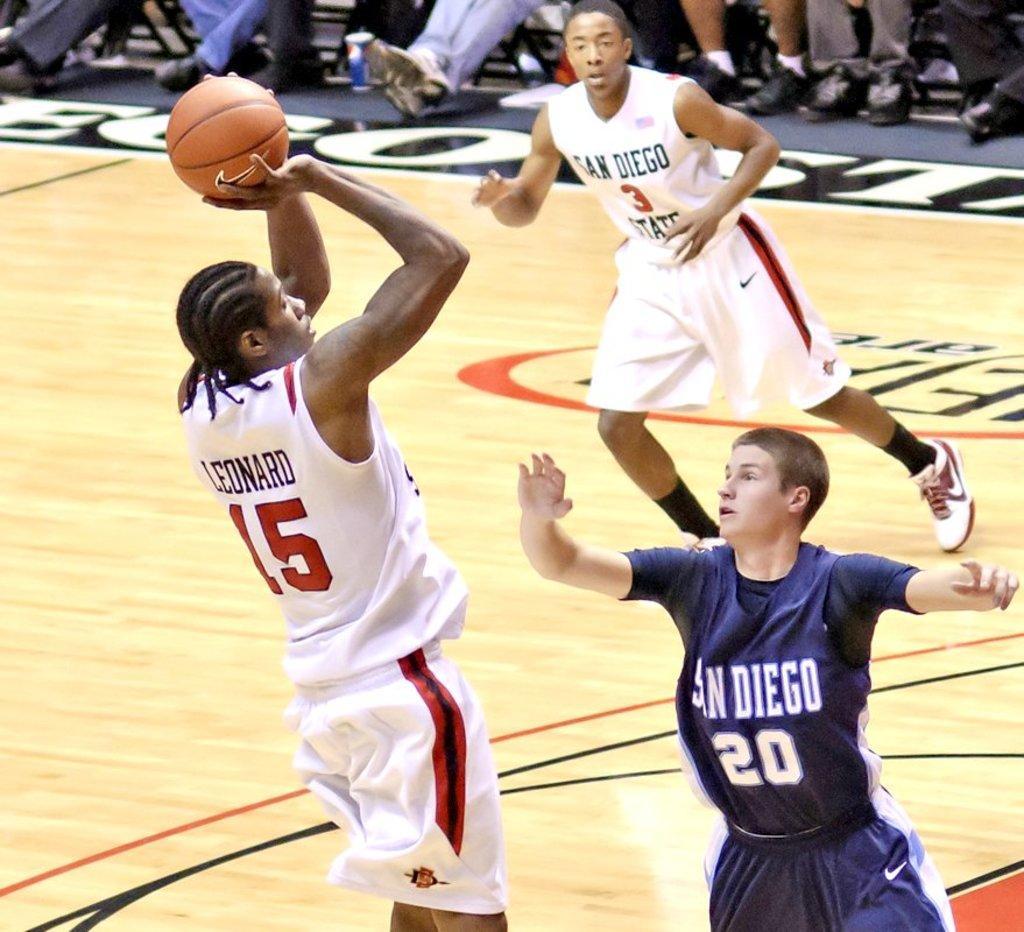In one or two sentences, can you explain what this image depicts? In this image there are people playing in the court. There is a ball. There is a floor. At the top we can see human legs with shoes. 